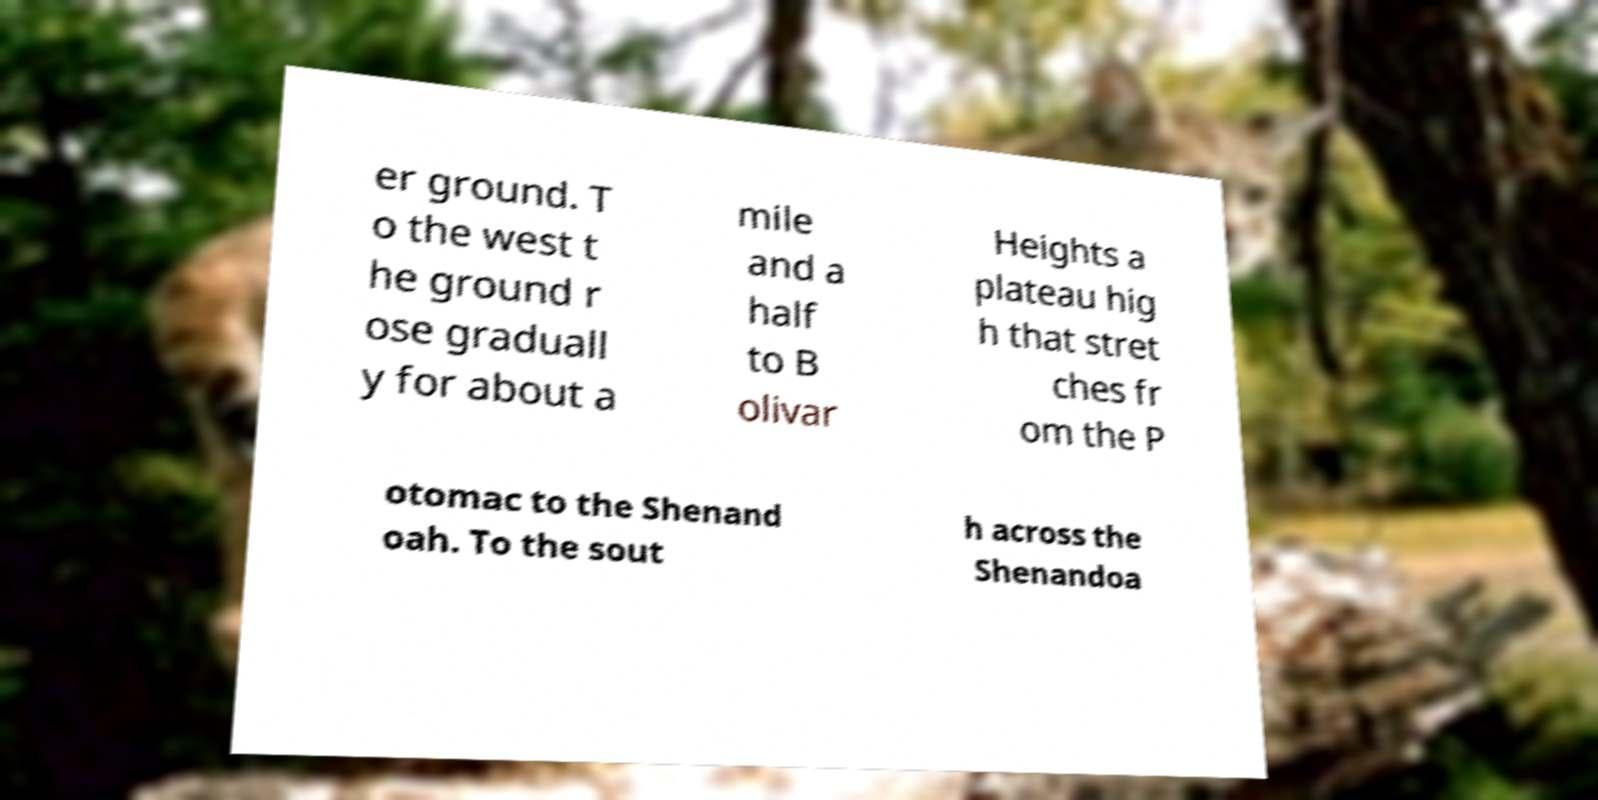What messages or text are displayed in this image? I need them in a readable, typed format. er ground. T o the west t he ground r ose graduall y for about a mile and a half to B olivar Heights a plateau hig h that stret ches fr om the P otomac to the Shenand oah. To the sout h across the Shenandoa 